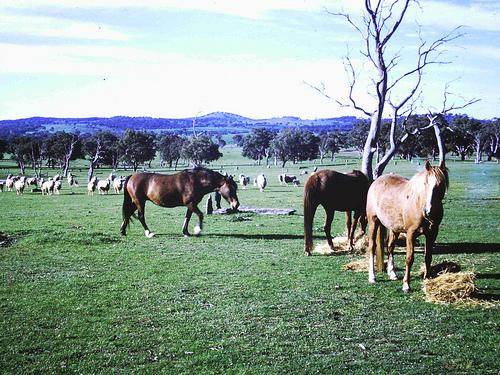Question: how many horses are there?
Choices:
A. Four.
B. Five.
C. Three.
D. Six.
Answer with the letter. Answer: C Question: how many animals are in the photo?
Choices:
A. More than ten.
B. 2.
C. 3.
D. 4.
Answer with the letter. Answer: A Question: what time of day is it?
Choices:
A. Morning.
B. Afternoon.
C. Tea time.
D. Noon.
Answer with the letter. Answer: B Question: what is below the horse?
Choices:
A. A dog.
B. Hay.
C. Grass.
D. A mouse.
Answer with the letter. Answer: B Question: where are the animals?
Choices:
A. A field.
B. In the barn.
C. At the track.
D. In the tree.
Answer with the letter. Answer: A Question: when was the photo taken?
Choices:
A. May.
B. In the daytime.
C. Ten years ago.
D. Yesterday.
Answer with the letter. Answer: B 